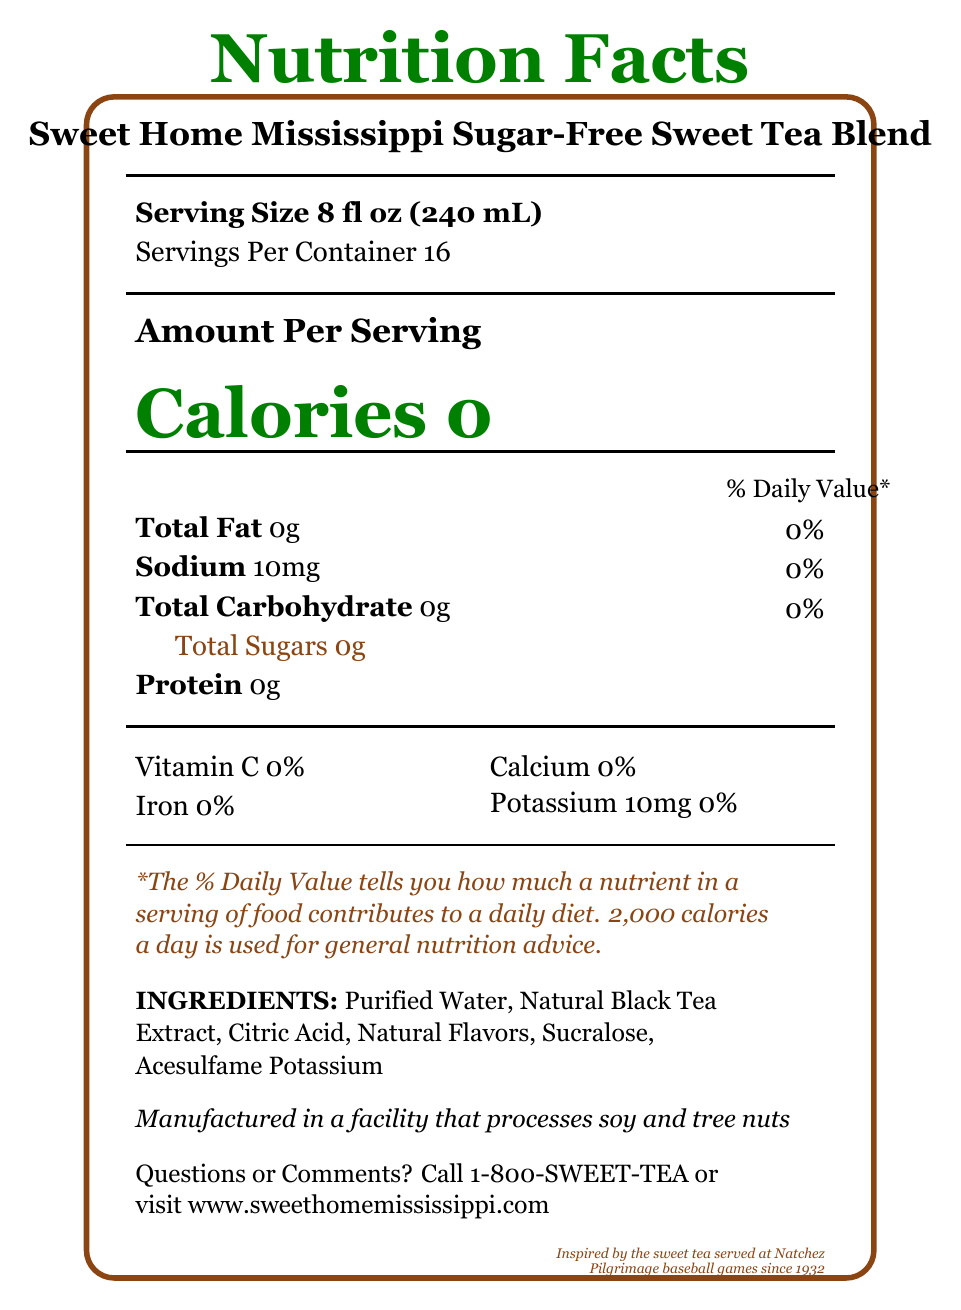how many servings are there per container? The document states that each container has 16 servings.
Answer: 16 what is the serving size of the sweet tea blend? The serving size specified in the document is 8 fl oz (240 mL).
Answer: 8 fl oz (240 mL) how many calories are in a single serving? The document clearly indicates that there are zero calories per serving.
Answer: 0 what is the sodium content in a single serving? The document lists the sodium content as 10mg per serving.
Answer: 10mg what ingredients are in the sweet tea blend? The list of ingredients mentioned in the document includes Purified Water, Natural Black Tea Extract, Citric Acid, Natural Flavors, Sucralose, and Acesulfame Potassium.
Answer: Purified Water, Natural Black Tea Extract, Citric Acid, Natural Flavors, Sucralose, Acesulfame Potassium what is the potassium content per serving? The document states that the potassium content is 10mg per serving.
Answer: 10mg which nutrient has the highest percentage daily value? A. Total Fat B. Sodium C. Total Carbohydrate D. Potassium All nutrients except for Potassium have a percentage daily value of 0%. Potassium has a value of 10mg but its percentage daily value isn't explicitly mentioned, implying minimal contribution.
Answer: D. Potassium where is the sweet tea blend manufactured? A. Jackson, MS B. Natchez, MS C. Vicksburg, MS D. Hattiesburg, MS The document states that the product is bottled by Southern Comfort Beverages in Natchez, MS 39120.
Answer: B. Natchez, MS is this sweet tea blend suitable for a diabetic-friendly diet? The marketing claims mention that the tea is "Perfect for Diabetic-Friendly Diets."
Answer: Yes are there any vitamins found in the sweet tea blend? The document indicates that there is 0% Vitamin C per serving.
Answer: No does the sweet tea blend contain any protein? The document specifies that there is 0g of protein per serving.
Answer: No how should the sweet tea blend be stored after opening? The storage instructions in the document advise to refrigerate the blend after opening and consume it within 7 days.
Answer: Refrigerate after opening and consume within 7 days describe the main idea of the document The document covers the nutritional details of the product, focusing on its health benefits and cultural significance.
Answer: The document provides detailed nutritional information about the Sweet Home Mississippi Sugar-Free Sweet Tea Blend, highlighting its zero-calorie and sugar-free content. It includes serving size, nutritional content, ingredients, storage instructions, marketing claims, and the manufacturing location, with an emphasis on its suitability for a diabetic-friendly diet and connection to Natchez baseball games. what is the caffeinated content of the blend? The document mentions natural black tea extract, which typically contains caffeine, but it does not specify the exact caffeine content.
Answer: Not enough information 